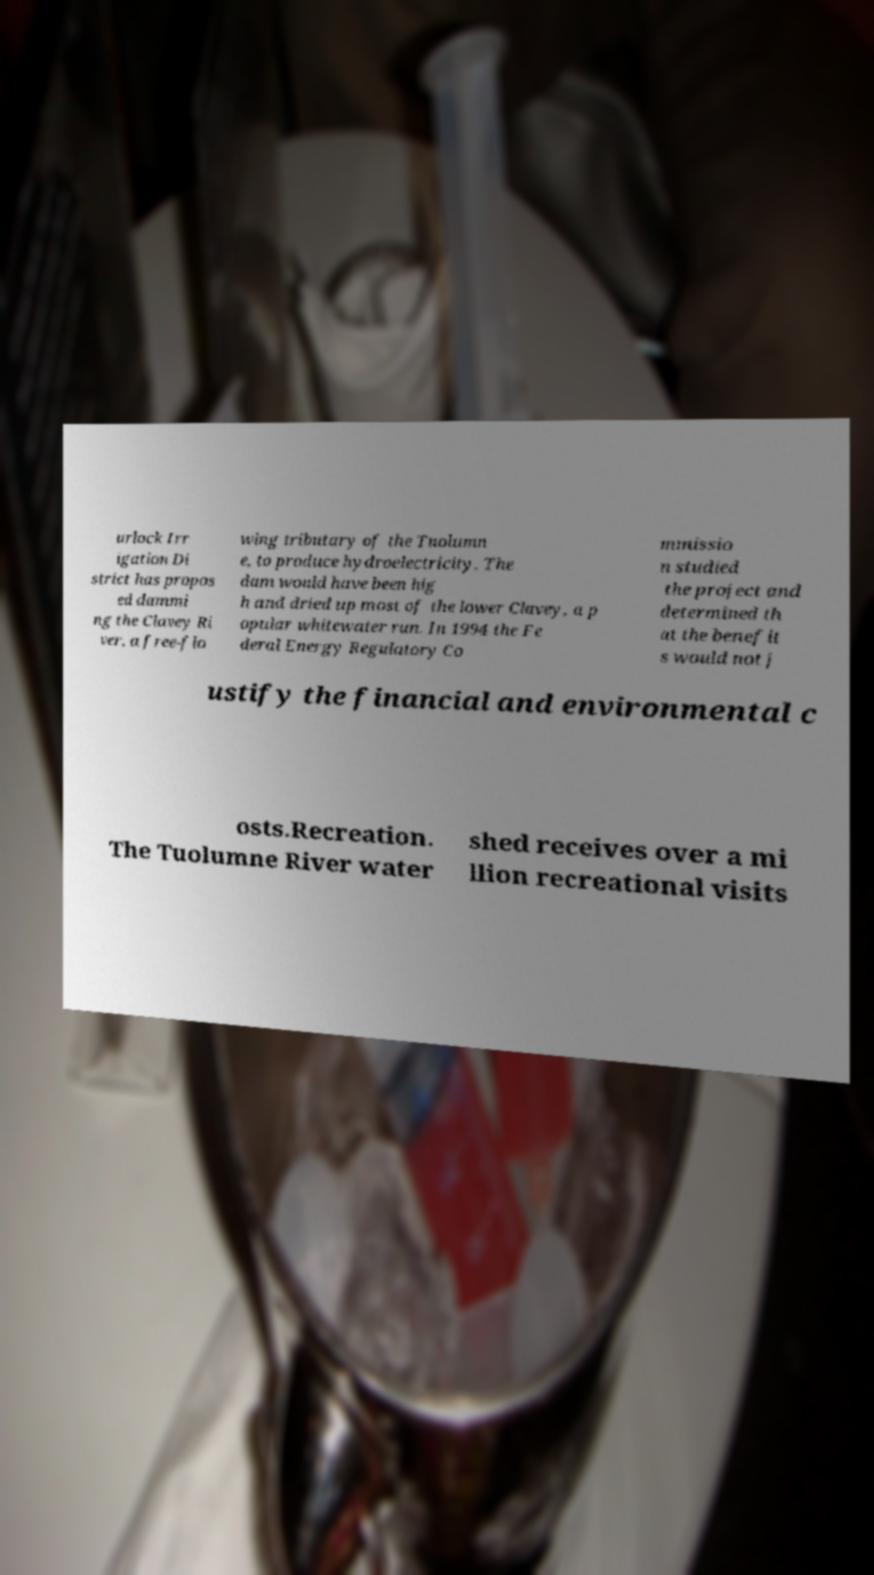What messages or text are displayed in this image? I need them in a readable, typed format. urlock Irr igation Di strict has propos ed dammi ng the Clavey Ri ver, a free-flo wing tributary of the Tuolumn e, to produce hydroelectricity. The dam would have been hig h and dried up most of the lower Clavey, a p opular whitewater run. In 1994 the Fe deral Energy Regulatory Co mmissio n studied the project and determined th at the benefit s would not j ustify the financial and environmental c osts.Recreation. The Tuolumne River water shed receives over a mi llion recreational visits 